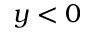Convert formula to latex. <formula><loc_0><loc_0><loc_500><loc_500>y < 0</formula> 